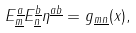<formula> <loc_0><loc_0><loc_500><loc_500>E ^ { \underline { a } } _ { \underline { m } } E ^ { \underline { b } } _ { \underline { n } } \eta ^ { \underline { a b } } = g _ { \underline { m n } } ( x ) ,</formula> 